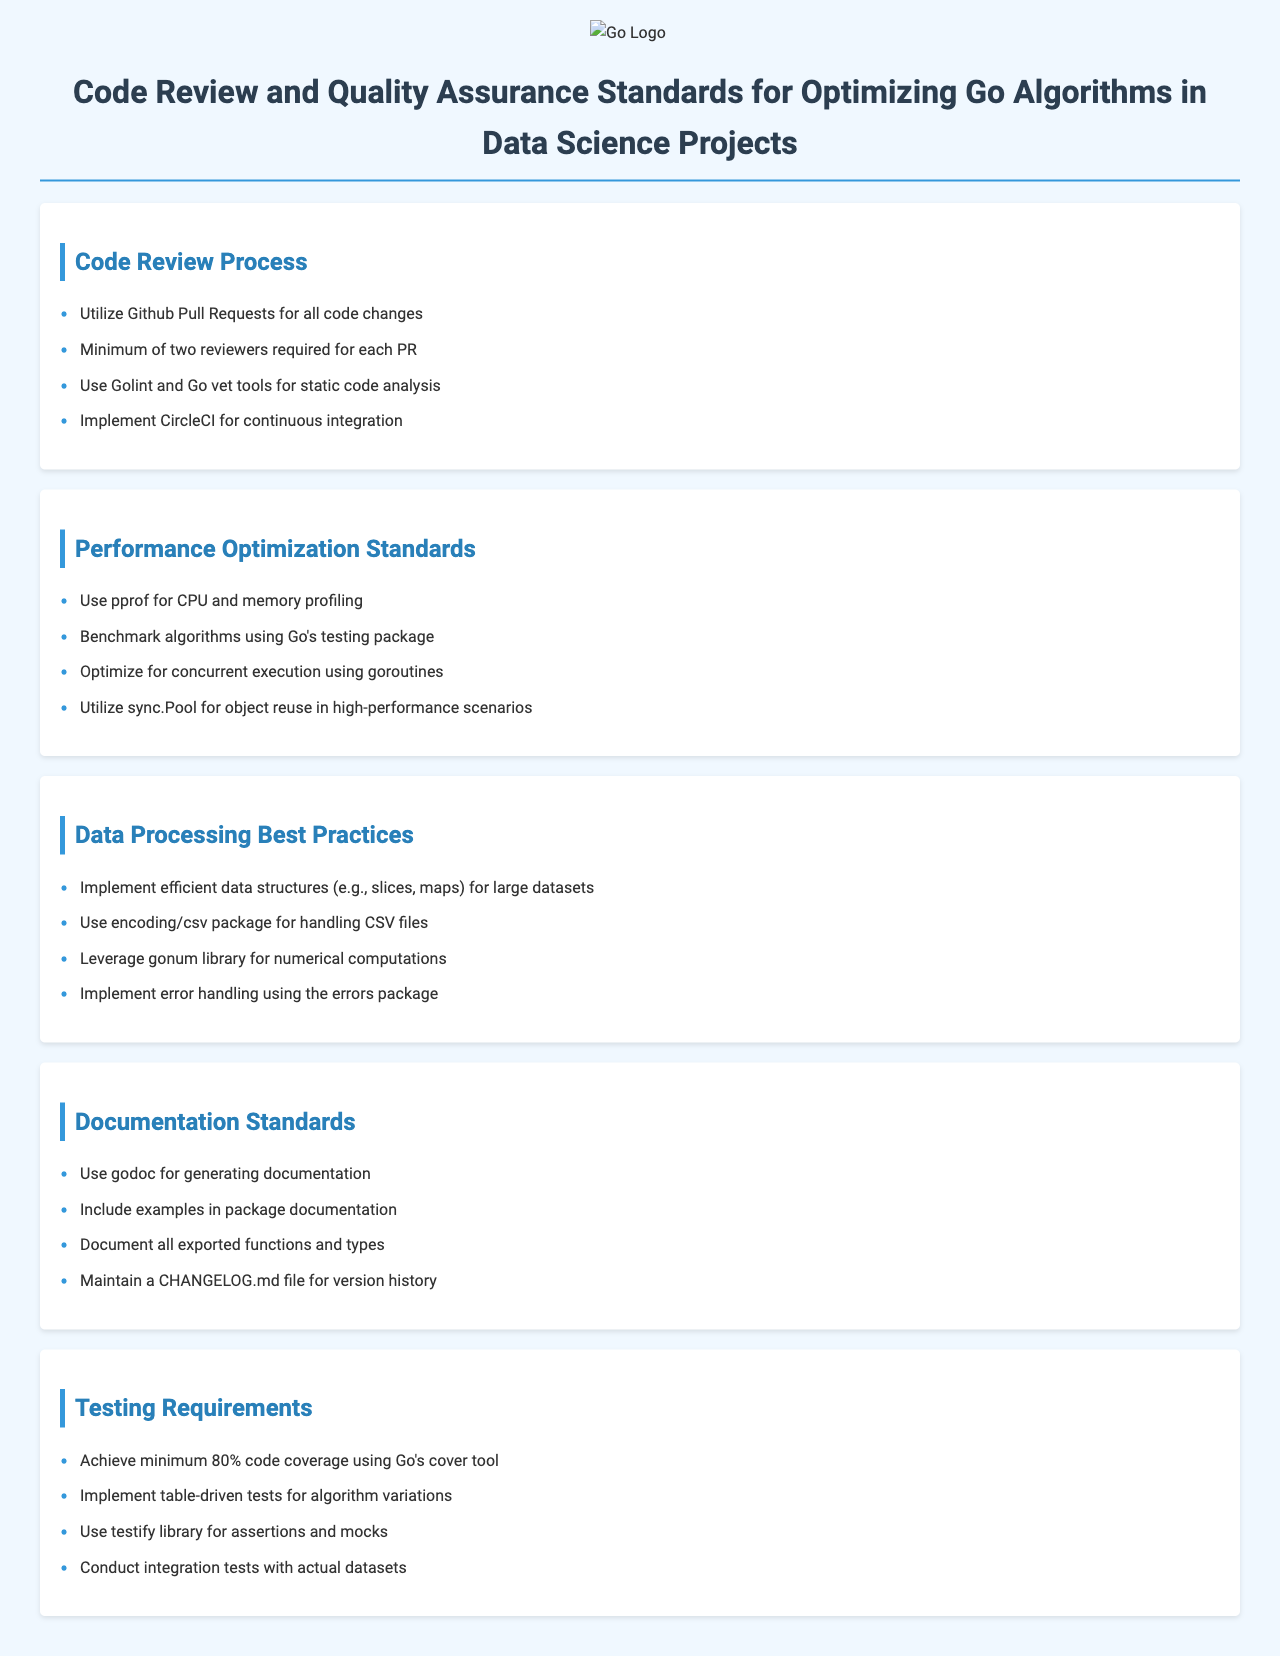What is the minimum number of reviewers required for each PR? The document states a minimum of two reviewers is required for each Pull Request.
Answer: two reviewers What tool is suggested for CPU and memory profiling? The document recommends using pprof for CPU and memory profiling.
Answer: pprof What percentage of code coverage is required for testing? The document specifies a minimum of 80% code coverage using Go's cover tool.
Answer: 80% Which library is advised for numerical computations? The document mentions the gonum library for numerical computations.
Answer: gonum What package should be used for handling CSV files? The document indicates that the encoding/csv package should be used for handling CSV files.
Answer: encoding/csv What is one method suggested for optimizing execution? The document suggests optimizing for concurrent execution using goroutines.
Answer: goroutines What documentation tool is recommended for generating documentation? The document recommends using godoc for generating documentation.
Answer: godoc How should error handling be implemented? The document directs to implement error handling using the errors package.
Answer: errors package What type of tests should be implemented for algorithm variations? The document states that table-driven tests should be implemented for algorithm variations.
Answer: table-driven tests 